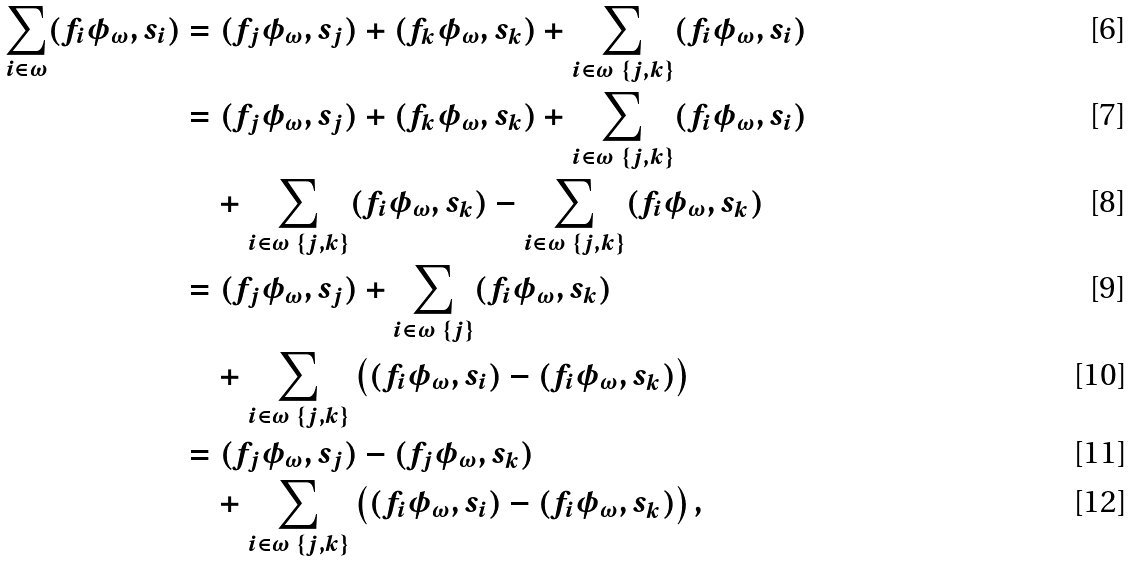Convert formula to latex. <formula><loc_0><loc_0><loc_500><loc_500>\sum _ { i \in \omega } ( f _ { i } \phi _ { \omega } , s _ { i } ) & = ( f _ { j } \phi _ { \omega } , s _ { j } ) + ( f _ { k } \phi _ { \omega } , s _ { k } ) + \sum _ { i \in \omega \ \{ j , k \} } ( f _ { i } \phi _ { \omega } , s _ { i } ) \\ & = ( f _ { j } \phi _ { \omega } , s _ { j } ) + ( f _ { k } \phi _ { \omega } , s _ { k } ) + \sum _ { i \in \omega \ \{ j , k \} } ( f _ { i } \phi _ { \omega } , s _ { i } ) \\ & \quad + \sum _ { i \in \omega \ \{ j , k \} } ( f _ { i } \phi _ { \omega } , s _ { k } ) - \sum _ { i \in \omega \ \{ j , k \} } ( f _ { i } \phi _ { \omega } , s _ { k } ) \\ & = ( f _ { j } \phi _ { \omega } , s _ { j } ) + \sum _ { i \in \omega \ \{ j \} } ( f _ { i } \phi _ { \omega } , s _ { k } ) \\ & \quad + \sum _ { i \in \omega \ \{ j , k \} } \left ( ( f _ { i } \phi _ { \omega } , s _ { i } ) - ( f _ { i } \phi _ { \omega } , s _ { k } ) \right ) \\ & = ( f _ { j } \phi _ { \omega } , s _ { j } ) - ( f _ { j } \phi _ { \omega } , s _ { k } ) \\ & \quad + \sum _ { i \in \omega \ \{ j , k \} } \left ( ( f _ { i } \phi _ { \omega } , s _ { i } ) - ( f _ { i } \phi _ { \omega } , s _ { k } ) \right ) ,</formula> 